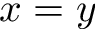Convert formula to latex. <formula><loc_0><loc_0><loc_500><loc_500>x = y</formula> 